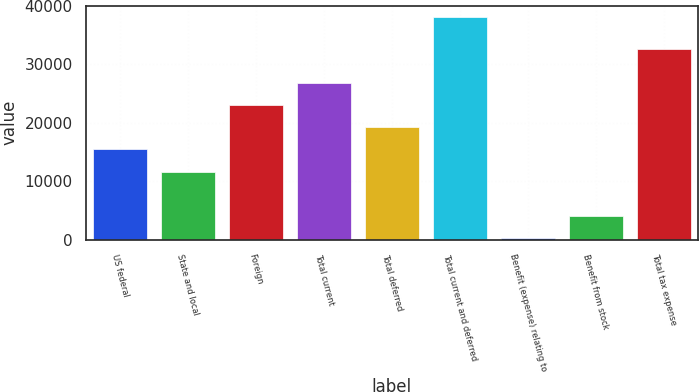Convert chart. <chart><loc_0><loc_0><loc_500><loc_500><bar_chart><fcel>US federal<fcel>State and local<fcel>Foreign<fcel>Total current<fcel>Total deferred<fcel>Total current and deferred<fcel>Benefit (expense) relating to<fcel>Benefit from stock<fcel>Total tax expense<nl><fcel>15426.4<fcel>11643.8<fcel>22991.6<fcel>26774.2<fcel>19209<fcel>38122<fcel>296<fcel>4078.6<fcel>32562<nl></chart> 